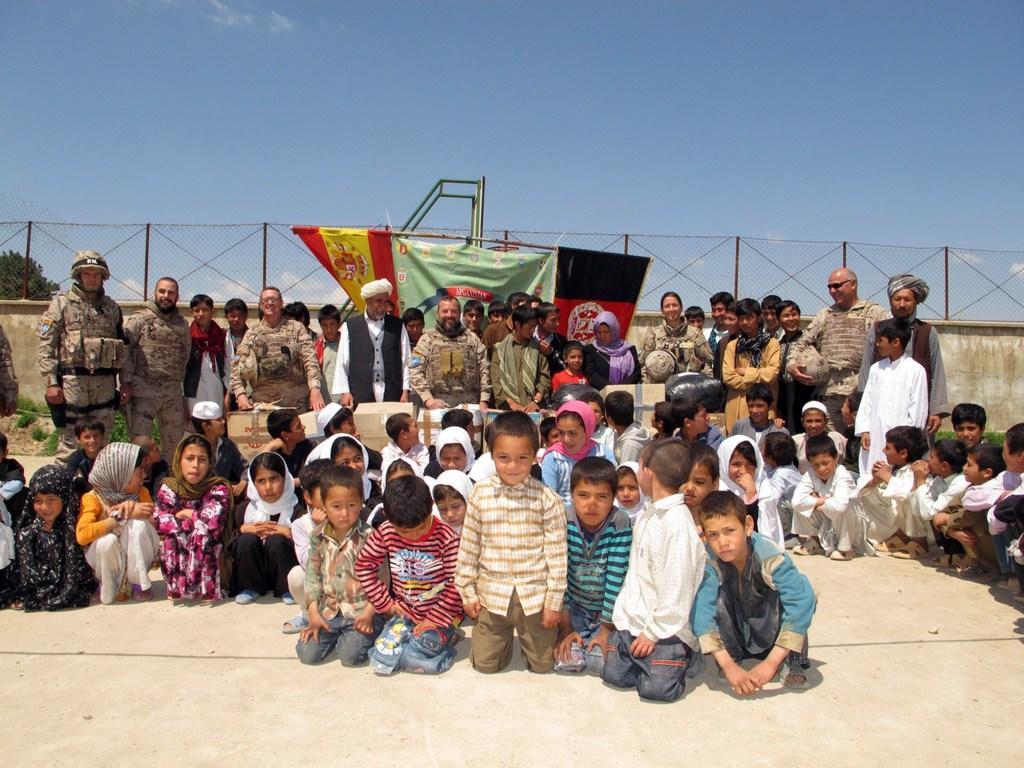Describe this image in one or two sentences. In this image I can see number of children are sitting on the ground and I can see few persons standing behind them. In the background I can see the flag, the wall, the metal fencing, a tree and the sky. 